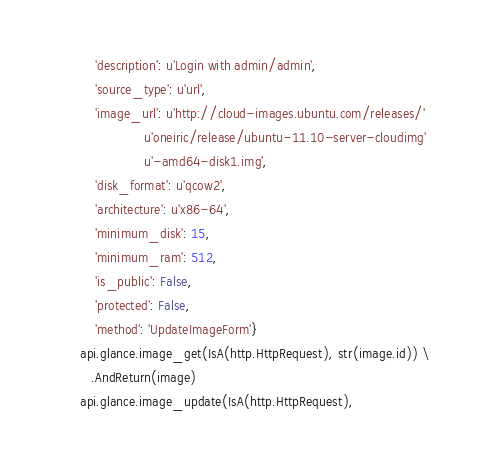<code> <loc_0><loc_0><loc_500><loc_500><_Python_>            'description': u'Login with admin/admin',
            'source_type': u'url',
            'image_url': u'http://cloud-images.ubuntu.com/releases/'
                         u'oneiric/release/ubuntu-11.10-server-cloudimg'
                         u'-amd64-disk1.img',
            'disk_format': u'qcow2',
            'architecture': u'x86-64',
            'minimum_disk': 15,
            'minimum_ram': 512,
            'is_public': False,
            'protected': False,
            'method': 'UpdateImageForm'}
        api.glance.image_get(IsA(http.HttpRequest), str(image.id)) \
           .AndReturn(image)
        api.glance.image_update(IsA(http.HttpRequest),</code> 